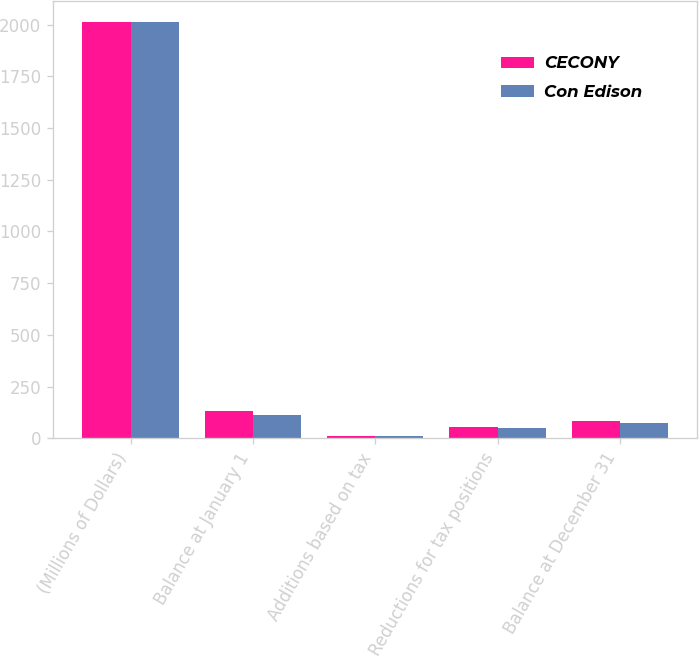Convert chart to OTSL. <chart><loc_0><loc_0><loc_500><loc_500><stacked_bar_chart><ecel><fcel>(Millions of Dollars)<fcel>Balance at January 1<fcel>Additions based on tax<fcel>Reductions for tax positions<fcel>Balance at December 31<nl><fcel>CECONY<fcel>2012<fcel>130<fcel>12<fcel>57<fcel>86<nl><fcel>Con Edison<fcel>2012<fcel>114<fcel>11<fcel>52<fcel>74<nl></chart> 